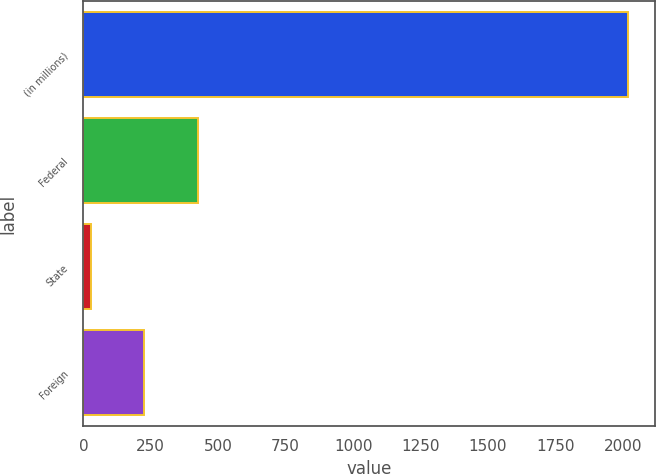<chart> <loc_0><loc_0><loc_500><loc_500><bar_chart><fcel>(in millions)<fcel>Federal<fcel>State<fcel>Foreign<nl><fcel>2018<fcel>425.2<fcel>27<fcel>226.1<nl></chart> 